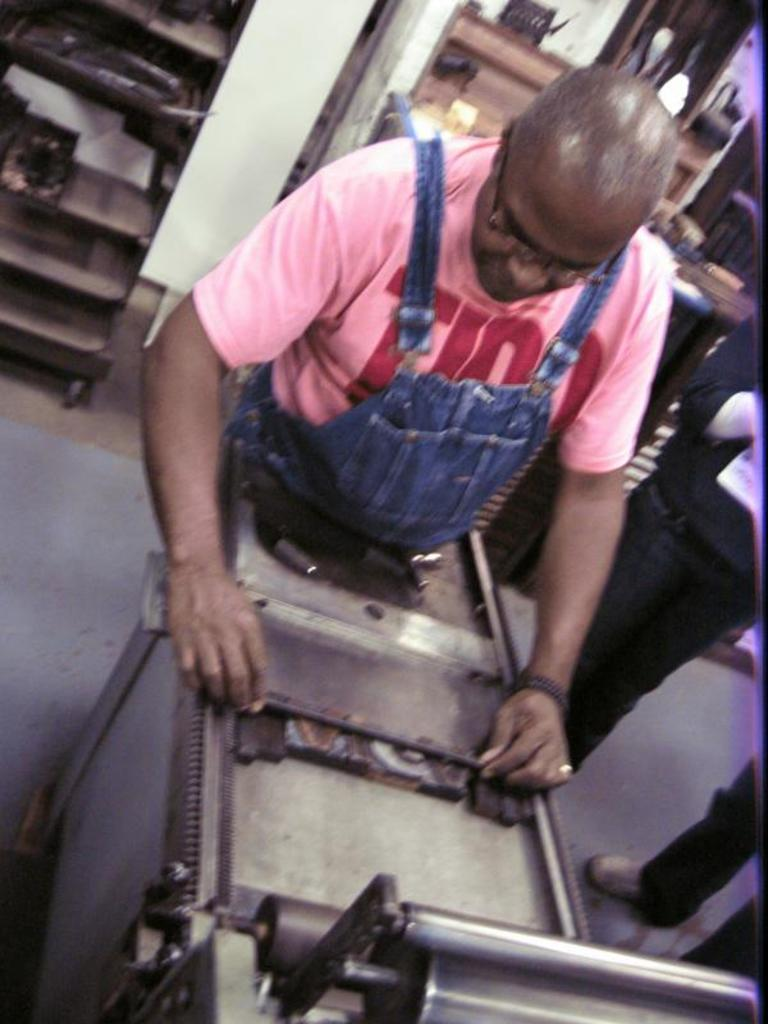What is the person in the image doing? The person is standing and holding a rod. Can you describe the people in the background of the image? There is a group of people at the back of the image. What can be seen in the background besides the people? There are machines visible in the background of the image. What type of zipper can be seen on the person's clothing in the image? There is no zipper visible on the person's clothing in the image. How many toes are visible on the person's feet in the image? The person's feet are not visible in the image, so we cannot determine the number of toes. 